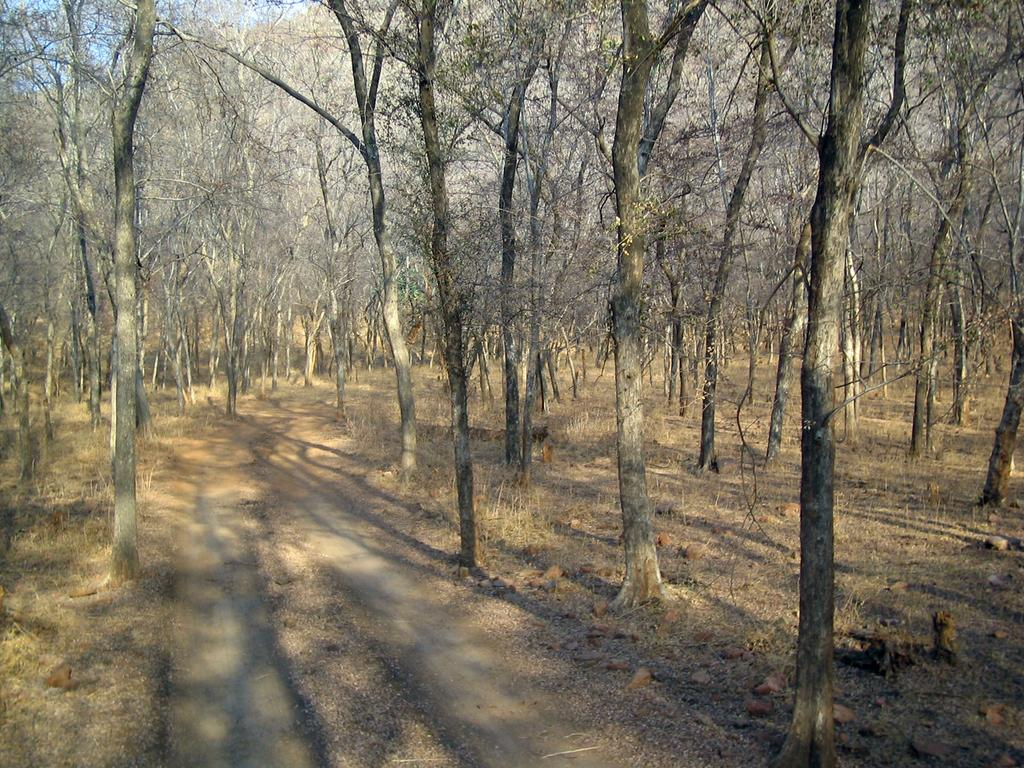What type of environment is depicted in the image? The image is taken in a wooded area. What types of vegetation can be seen in the image? There are trees, shrubs, and grass in the image. Is there any indication of a trail or path in the image? Yes, there is a path in the center of the image. What date is marked on the calendar in the image? There is no calendar present in the image. What type of destruction can be seen in the image? There is no destruction present in the image; it depicts a natural, wooded environment. 